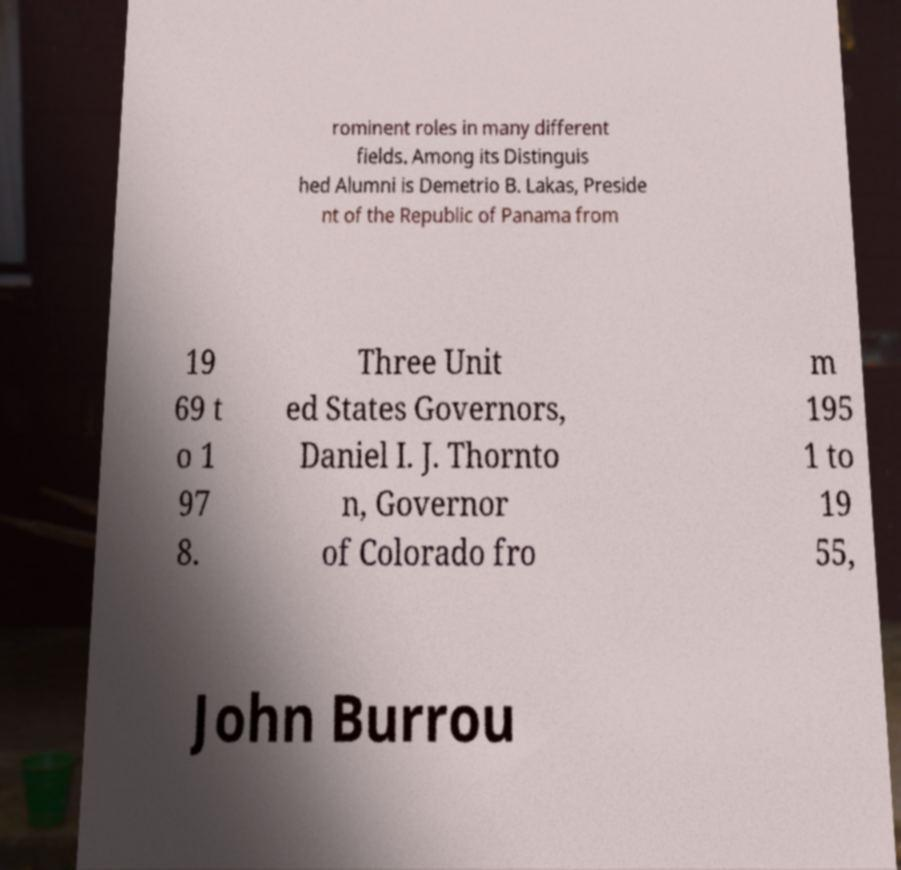Can you accurately transcribe the text from the provided image for me? rominent roles in many different fields. Among its Distinguis hed Alumni is Demetrio B. Lakas, Preside nt of the Republic of Panama from 19 69 t o 1 97 8. Three Unit ed States Governors, Daniel I. J. Thornto n, Governor of Colorado fro m 195 1 to 19 55, John Burrou 